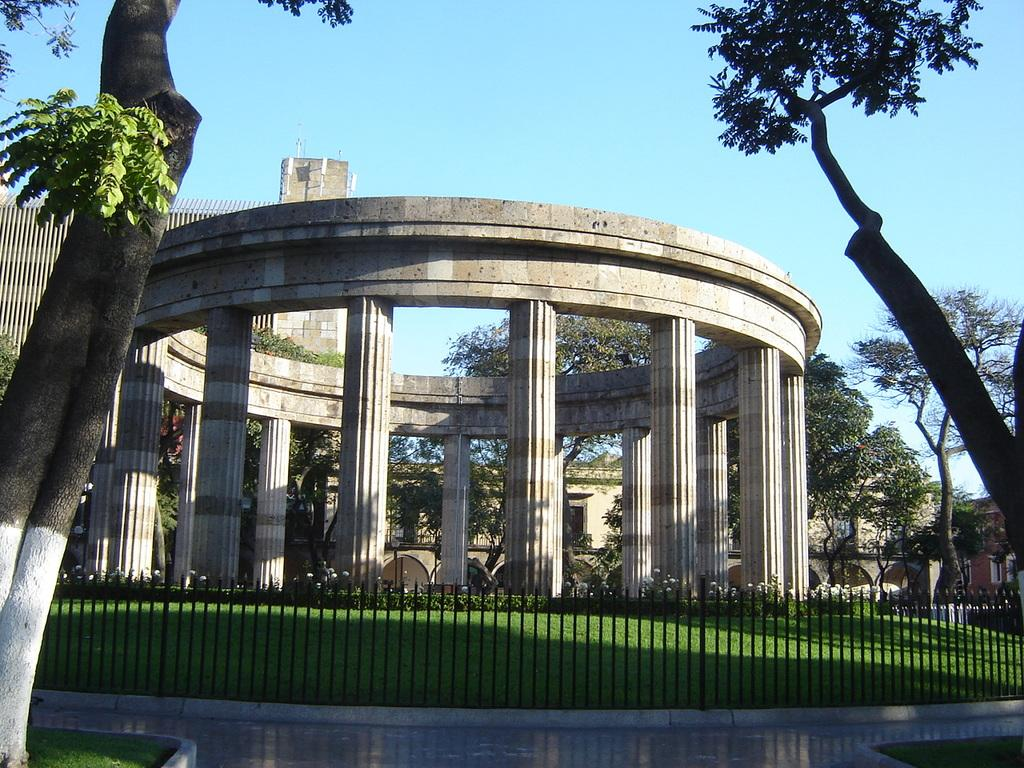What is the main subject of the image? There is a building at the center of the image. What can be seen in front of the building? There are trees, plants, grass, and a railing in front of the building. What is visible in the background of the image? The sky is visible in the background of the image. How many frogs can be seen jumping on the building in the image? There are no frogs present in the image, so it is not possible to determine how many might be jumping on the building. 